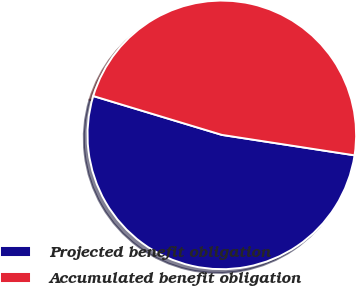Convert chart to OTSL. <chart><loc_0><loc_0><loc_500><loc_500><pie_chart><fcel>Projected benefit obligation<fcel>Accumulated benefit obligation<nl><fcel>52.24%<fcel>47.76%<nl></chart> 